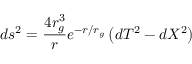Convert formula to latex. <formula><loc_0><loc_0><loc_500><loc_500>d s ^ { 2 } = \frac { 4 r _ { g } ^ { 3 } } { r } e ^ { - r / r _ { g } } \left ( d T ^ { 2 } - d X ^ { 2 } \right )</formula> 